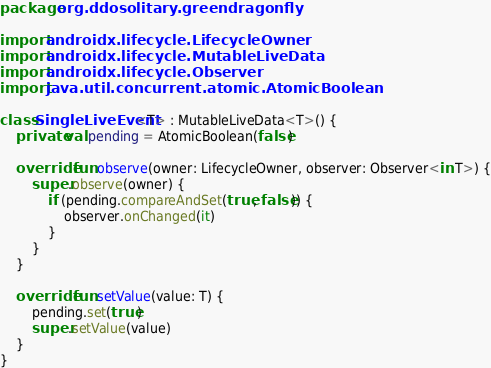Convert code to text. <code><loc_0><loc_0><loc_500><loc_500><_Kotlin_>package org.ddosolitary.greendragonfly

import androidx.lifecycle.LifecycleOwner
import androidx.lifecycle.MutableLiveData
import androidx.lifecycle.Observer
import java.util.concurrent.atomic.AtomicBoolean

class SingleLiveEvent<T> : MutableLiveData<T>() {
	private val pending = AtomicBoolean(false)

	override fun observe(owner: LifecycleOwner, observer: Observer<in T>) {
		super.observe(owner) {
			if (pending.compareAndSet(true, false)) {
				observer.onChanged(it)
			}
		}
	}

	override fun setValue(value: T) {
		pending.set(true)
		super.setValue(value)
	}
}
</code> 